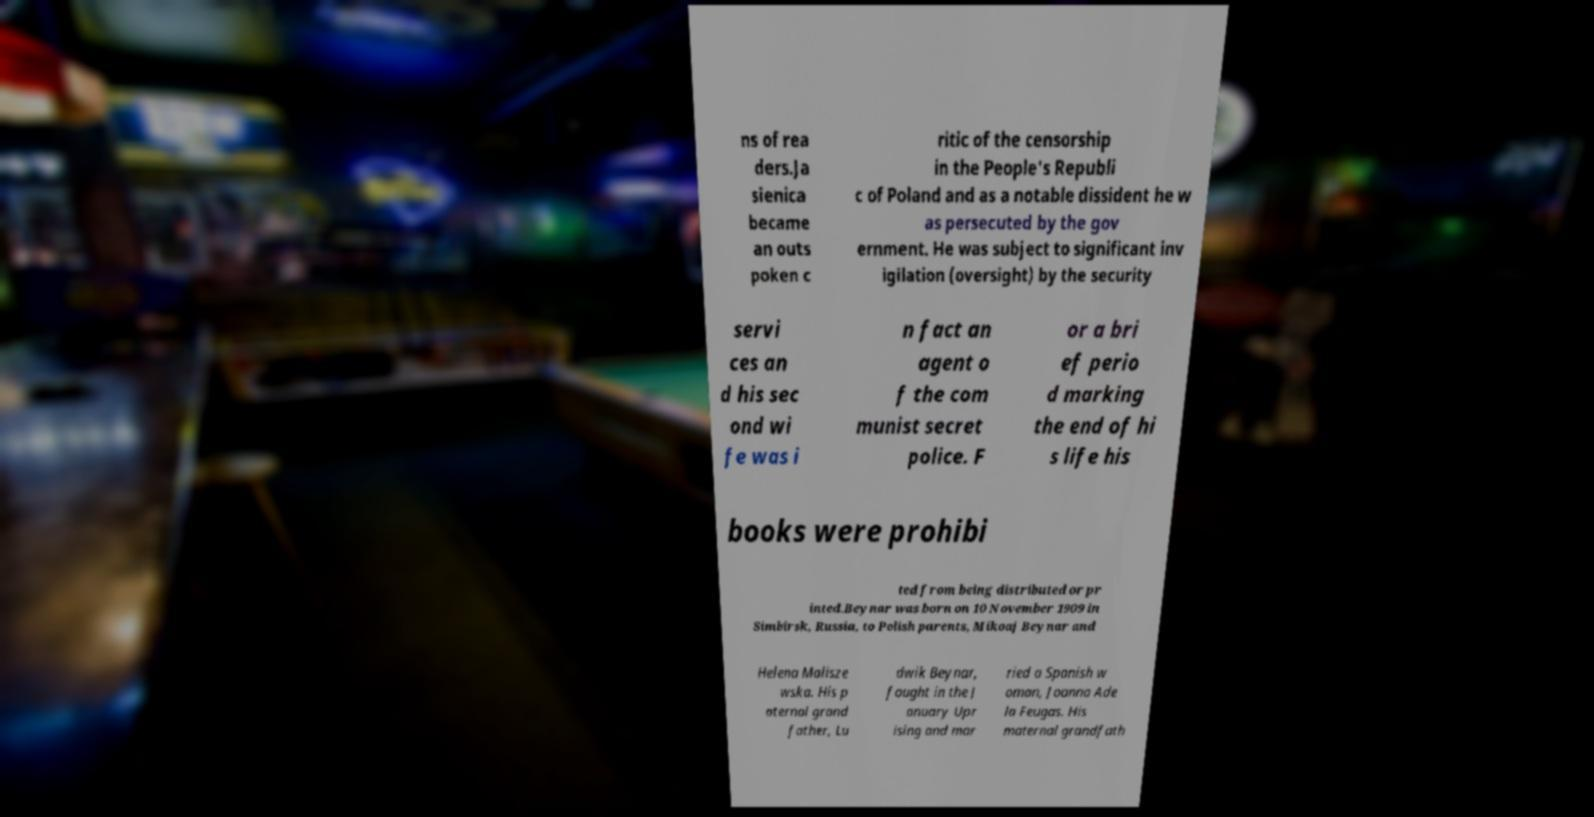For documentation purposes, I need the text within this image transcribed. Could you provide that? ns of rea ders.Ja sienica became an outs poken c ritic of the censorship in the People's Republi c of Poland and as a notable dissident he w as persecuted by the gov ernment. He was subject to significant inv igilation (oversight) by the security servi ces an d his sec ond wi fe was i n fact an agent o f the com munist secret police. F or a bri ef perio d marking the end of hi s life his books were prohibi ted from being distributed or pr inted.Beynar was born on 10 November 1909 in Simbirsk, Russia, to Polish parents, Mikoaj Beynar and Helena Malisze wska. His p aternal grand father, Lu dwik Beynar, fought in the J anuary Upr ising and mar ried a Spanish w oman, Joanna Ade la Feugas. His maternal grandfath 